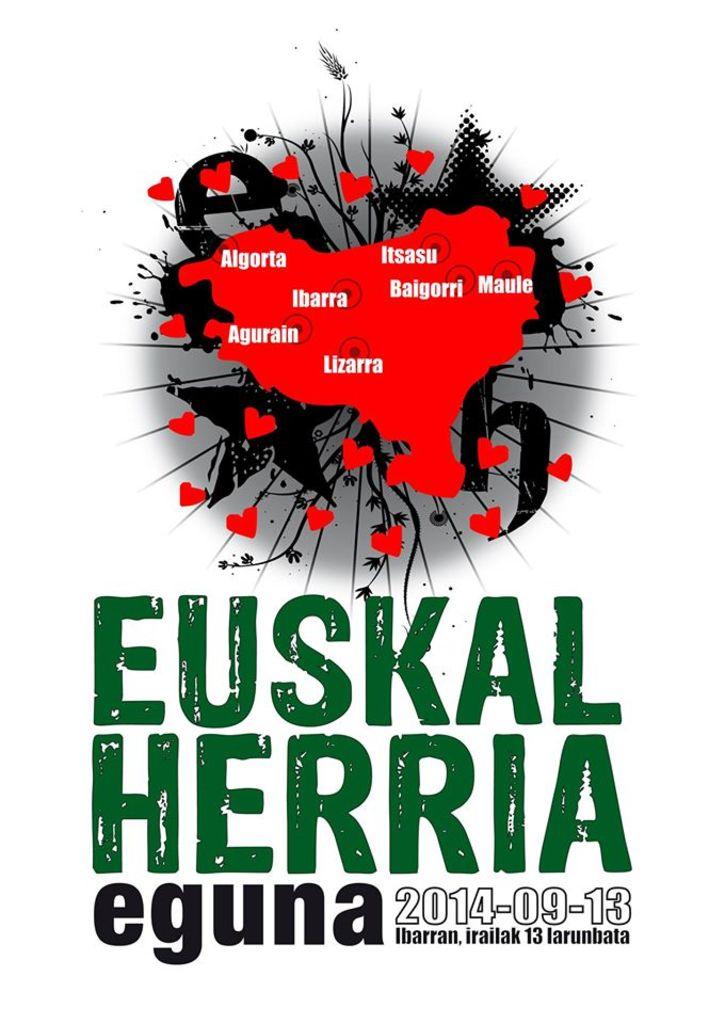What is the date on the sign?
Your answer should be compact. 2014-09-13. 